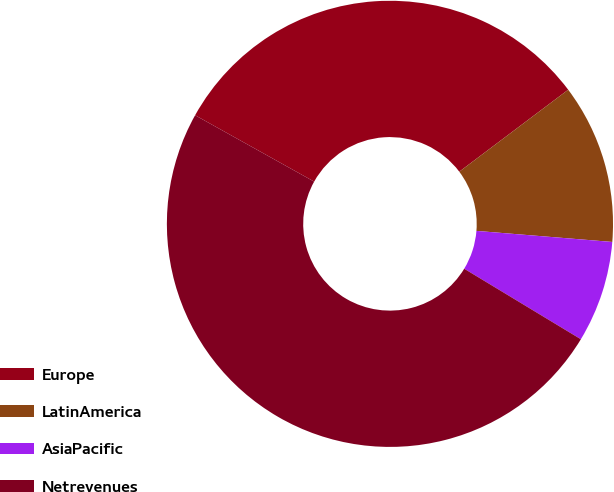Convert chart to OTSL. <chart><loc_0><loc_0><loc_500><loc_500><pie_chart><fcel>Europe<fcel>LatinAmerica<fcel>AsiaPacific<fcel>Netrevenues<nl><fcel>31.64%<fcel>11.56%<fcel>7.36%<fcel>49.44%<nl></chart> 